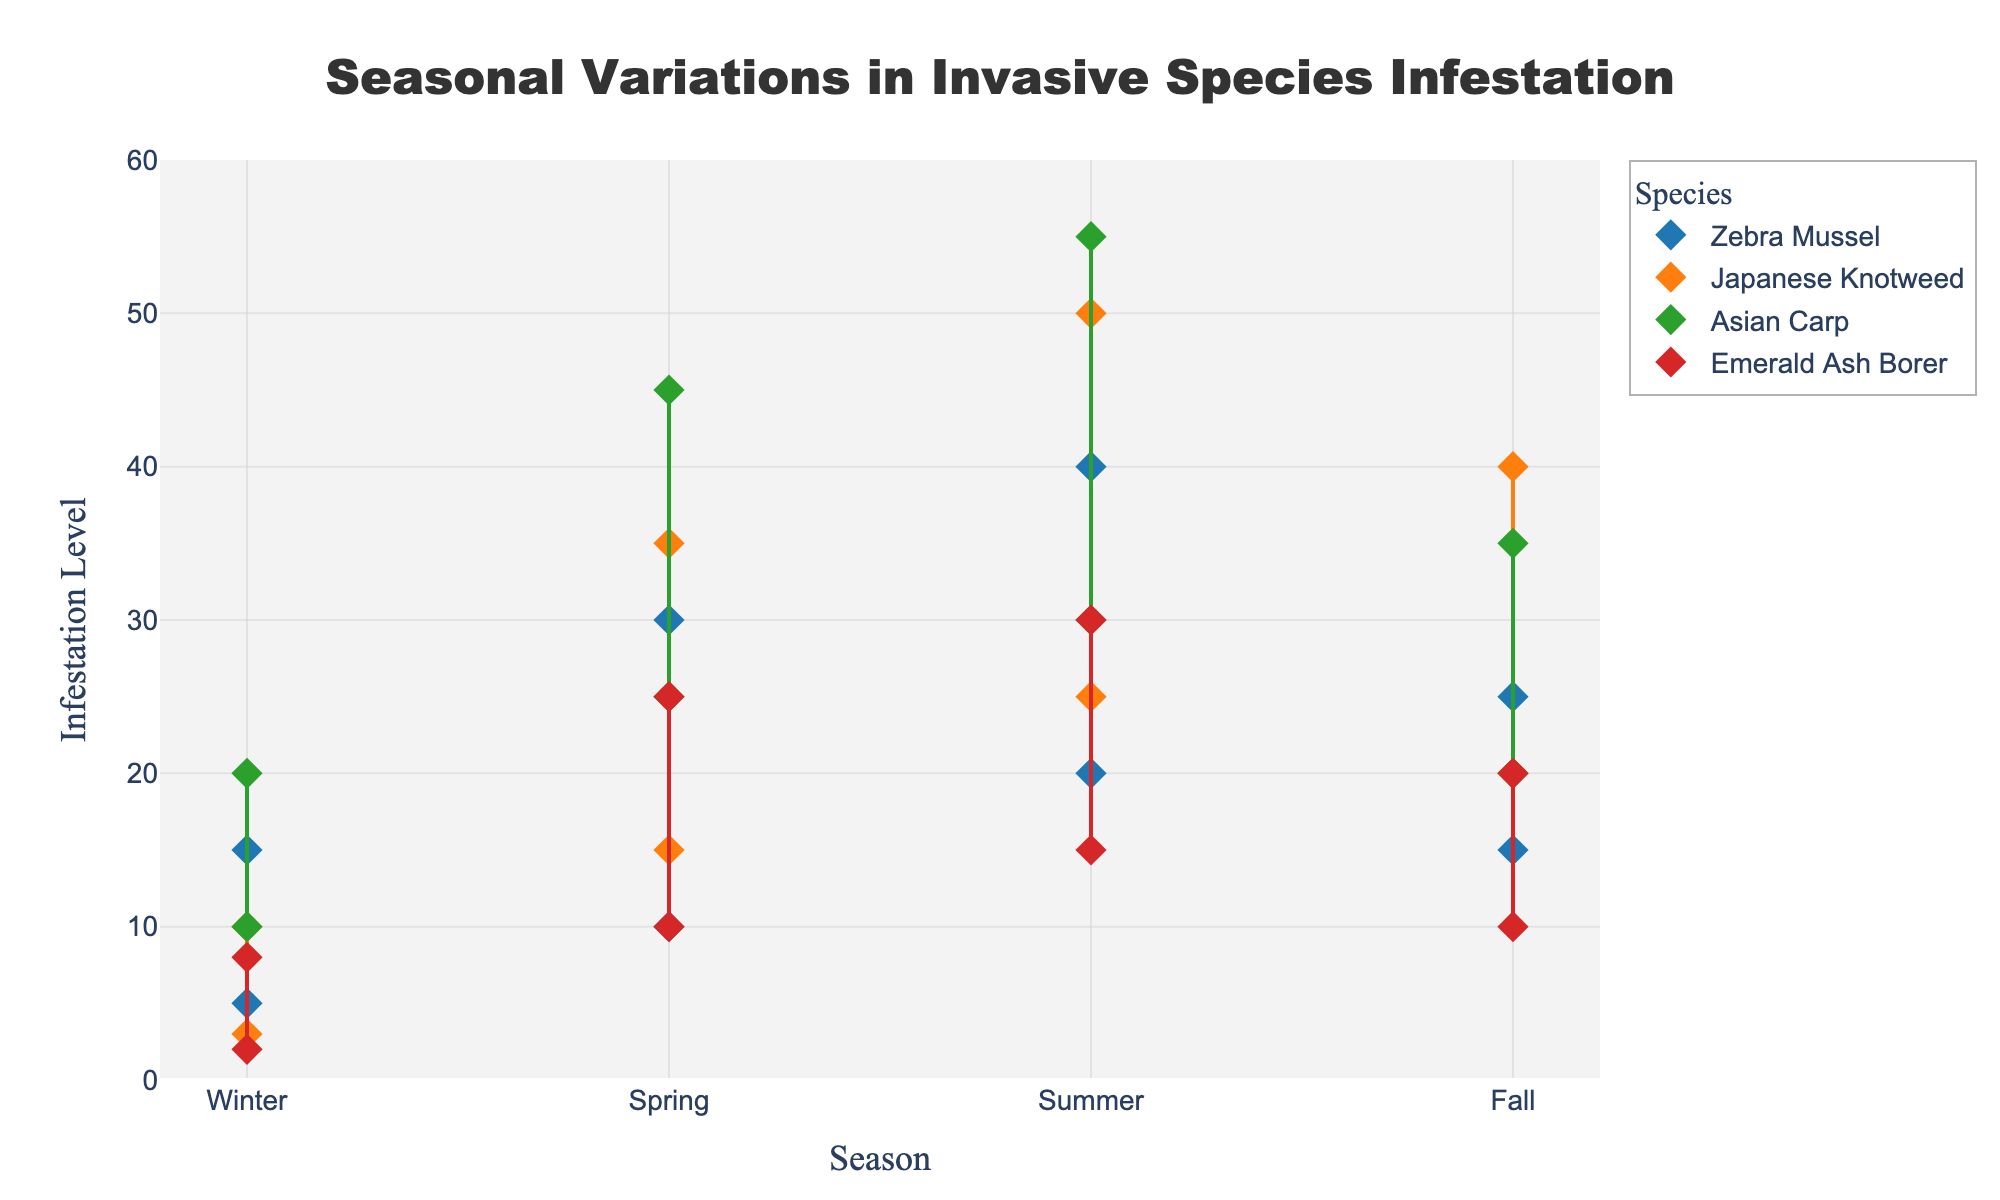what is the title of the plot? The title is displayed prominently at the top of the plot. It is "Seasonal Variations in Invasive Species Infestation".
Answer: Seasonal Variations in Invasive Species Infestation What is the range of infestation levels for Zebra Mussel in the Summer? Locate the data points for Zebra Mussel in the Summer on the plot, and read the minimum and maximum infestation levels, which are connected by a line. The values are 20 and 40, respectively.
Answer: 20-40 Which species has the highest maximum infestation level in the Summer? Compare the highest endpoints of the lines representing infestation levels for each species during the Summer. The species with the highest endpoint is Asian Carp, which reaches up to 55.
Answer: Asian Carp How does the infestation level of Emerald Ash Borer in Winter compare to its level in Spring? Check the minimum and maximum infestation levels for Emerald Ash Borer in Winter and compare them to those in Spring. The infestation level in Winter is 2-8, while in Spring it is 10-25, showing a clear increase.
Answer: It increases What is the maximum infestation level of Japanese Knotweed in the Fall? Locate the Japanese Knotweed data for the Fall and identify the highest point of the line segment, which is 40.
Answer: 40 Which season generally shows the highest infestation levels across all species? By observing the plot, identify which season has the highest values for most species. Summer shows the highest infestation levels for all species.
Answer: Summer Which species has the smallest variation in infestation levels in Winter? Compare the difference between the minimum and maximum infestation levels for all species in the Winter. Emerald Ash Borer has the smallest range with values from 2 to 8, making the variation 6.
Answer: Emerald Ash Borer What is the difference between the maximum infestation levels of Zebra Mussel in Winter and Summer? Determine the maximum infestation levels of Zebra Mussel in Winter (15) and Summer (40), then subtract the Winter value from the Summer value: 40 - 15 = 25.
Answer: 25 How does infestation level variability for Asian Carp in Spring compare to Fall? Check the range of infestation levels for Asian Carp in Spring (25-45) and Fall (20-35). In Spring, the range is 20 (45-25), and in Fall, it is 15 (35-20), meaning variability is higher in Spring.
Answer: Greater in Spring Which species shows an increase in infestation levels from Winter to Fall and then a decrease in Winter? Review each species for their infestation levels over the seasons. Zebra Mussel shows an increase from Winter to Summer and then a decrease in Fall and Winter.
Answer: Zebra Mussel 